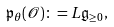<formula> <loc_0><loc_0><loc_500><loc_500>\mathfrak { p } _ { \theta } ( \mathcal { O } ) \colon = L \mathfrak { g } _ { \geq 0 } ,</formula> 